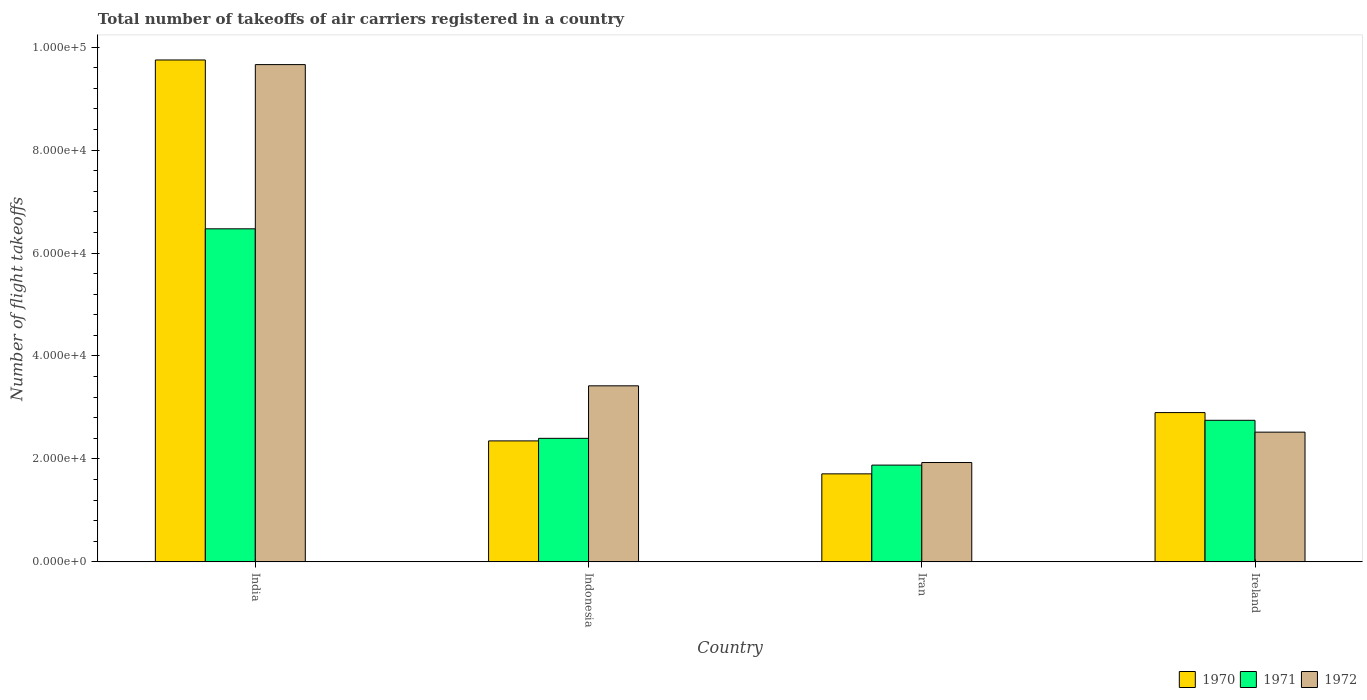How many different coloured bars are there?
Offer a terse response. 3. What is the label of the 3rd group of bars from the left?
Make the answer very short. Iran. What is the total number of flight takeoffs in 1970 in Indonesia?
Provide a succinct answer. 2.35e+04. Across all countries, what is the maximum total number of flight takeoffs in 1971?
Provide a short and direct response. 6.47e+04. Across all countries, what is the minimum total number of flight takeoffs in 1970?
Make the answer very short. 1.71e+04. In which country was the total number of flight takeoffs in 1970 maximum?
Make the answer very short. India. In which country was the total number of flight takeoffs in 1972 minimum?
Keep it short and to the point. Iran. What is the total total number of flight takeoffs in 1971 in the graph?
Provide a short and direct response. 1.35e+05. What is the difference between the total number of flight takeoffs in 1970 in India and that in Indonesia?
Offer a very short reply. 7.40e+04. What is the difference between the total number of flight takeoffs in 1972 in India and the total number of flight takeoffs in 1971 in Iran?
Keep it short and to the point. 7.78e+04. What is the average total number of flight takeoffs in 1972 per country?
Give a very brief answer. 4.38e+04. What is the difference between the total number of flight takeoffs of/in 1972 and total number of flight takeoffs of/in 1970 in Iran?
Your answer should be compact. 2200. What is the ratio of the total number of flight takeoffs in 1971 in India to that in Ireland?
Make the answer very short. 2.35. Is the difference between the total number of flight takeoffs in 1972 in Indonesia and Ireland greater than the difference between the total number of flight takeoffs in 1970 in Indonesia and Ireland?
Provide a short and direct response. Yes. What is the difference between the highest and the second highest total number of flight takeoffs in 1972?
Keep it short and to the point. 7.14e+04. What is the difference between the highest and the lowest total number of flight takeoffs in 1972?
Offer a very short reply. 7.73e+04. Is it the case that in every country, the sum of the total number of flight takeoffs in 1971 and total number of flight takeoffs in 1972 is greater than the total number of flight takeoffs in 1970?
Offer a terse response. Yes. How many bars are there?
Ensure brevity in your answer.  12. Are all the bars in the graph horizontal?
Provide a succinct answer. No. Does the graph contain any zero values?
Provide a short and direct response. No. What is the title of the graph?
Provide a succinct answer. Total number of takeoffs of air carriers registered in a country. What is the label or title of the Y-axis?
Keep it short and to the point. Number of flight takeoffs. What is the Number of flight takeoffs of 1970 in India?
Offer a very short reply. 9.75e+04. What is the Number of flight takeoffs in 1971 in India?
Offer a terse response. 6.47e+04. What is the Number of flight takeoffs of 1972 in India?
Provide a succinct answer. 9.66e+04. What is the Number of flight takeoffs of 1970 in Indonesia?
Your response must be concise. 2.35e+04. What is the Number of flight takeoffs in 1971 in Indonesia?
Your answer should be very brief. 2.40e+04. What is the Number of flight takeoffs in 1972 in Indonesia?
Offer a very short reply. 3.42e+04. What is the Number of flight takeoffs in 1970 in Iran?
Your answer should be compact. 1.71e+04. What is the Number of flight takeoffs of 1971 in Iran?
Ensure brevity in your answer.  1.88e+04. What is the Number of flight takeoffs of 1972 in Iran?
Ensure brevity in your answer.  1.93e+04. What is the Number of flight takeoffs in 1970 in Ireland?
Provide a succinct answer. 2.90e+04. What is the Number of flight takeoffs of 1971 in Ireland?
Offer a very short reply. 2.75e+04. What is the Number of flight takeoffs in 1972 in Ireland?
Ensure brevity in your answer.  2.52e+04. Across all countries, what is the maximum Number of flight takeoffs in 1970?
Your answer should be compact. 9.75e+04. Across all countries, what is the maximum Number of flight takeoffs in 1971?
Your answer should be very brief. 6.47e+04. Across all countries, what is the maximum Number of flight takeoffs of 1972?
Make the answer very short. 9.66e+04. Across all countries, what is the minimum Number of flight takeoffs of 1970?
Your response must be concise. 1.71e+04. Across all countries, what is the minimum Number of flight takeoffs in 1971?
Your response must be concise. 1.88e+04. Across all countries, what is the minimum Number of flight takeoffs in 1972?
Offer a very short reply. 1.93e+04. What is the total Number of flight takeoffs of 1970 in the graph?
Provide a short and direct response. 1.67e+05. What is the total Number of flight takeoffs of 1971 in the graph?
Ensure brevity in your answer.  1.35e+05. What is the total Number of flight takeoffs of 1972 in the graph?
Provide a succinct answer. 1.75e+05. What is the difference between the Number of flight takeoffs of 1970 in India and that in Indonesia?
Ensure brevity in your answer.  7.40e+04. What is the difference between the Number of flight takeoffs of 1971 in India and that in Indonesia?
Your answer should be compact. 4.07e+04. What is the difference between the Number of flight takeoffs in 1972 in India and that in Indonesia?
Ensure brevity in your answer.  6.24e+04. What is the difference between the Number of flight takeoffs in 1970 in India and that in Iran?
Provide a succinct answer. 8.04e+04. What is the difference between the Number of flight takeoffs of 1971 in India and that in Iran?
Make the answer very short. 4.59e+04. What is the difference between the Number of flight takeoffs of 1972 in India and that in Iran?
Your response must be concise. 7.73e+04. What is the difference between the Number of flight takeoffs in 1970 in India and that in Ireland?
Offer a very short reply. 6.85e+04. What is the difference between the Number of flight takeoffs in 1971 in India and that in Ireland?
Your response must be concise. 3.72e+04. What is the difference between the Number of flight takeoffs of 1972 in India and that in Ireland?
Provide a short and direct response. 7.14e+04. What is the difference between the Number of flight takeoffs of 1970 in Indonesia and that in Iran?
Make the answer very short. 6400. What is the difference between the Number of flight takeoffs of 1971 in Indonesia and that in Iran?
Your answer should be very brief. 5200. What is the difference between the Number of flight takeoffs of 1972 in Indonesia and that in Iran?
Your answer should be very brief. 1.49e+04. What is the difference between the Number of flight takeoffs of 1970 in Indonesia and that in Ireland?
Your answer should be compact. -5500. What is the difference between the Number of flight takeoffs in 1971 in Indonesia and that in Ireland?
Offer a very short reply. -3500. What is the difference between the Number of flight takeoffs in 1972 in Indonesia and that in Ireland?
Your answer should be compact. 9000. What is the difference between the Number of flight takeoffs in 1970 in Iran and that in Ireland?
Your answer should be very brief. -1.19e+04. What is the difference between the Number of flight takeoffs in 1971 in Iran and that in Ireland?
Offer a terse response. -8700. What is the difference between the Number of flight takeoffs of 1972 in Iran and that in Ireland?
Make the answer very short. -5900. What is the difference between the Number of flight takeoffs of 1970 in India and the Number of flight takeoffs of 1971 in Indonesia?
Provide a short and direct response. 7.35e+04. What is the difference between the Number of flight takeoffs in 1970 in India and the Number of flight takeoffs in 1972 in Indonesia?
Make the answer very short. 6.33e+04. What is the difference between the Number of flight takeoffs of 1971 in India and the Number of flight takeoffs of 1972 in Indonesia?
Make the answer very short. 3.05e+04. What is the difference between the Number of flight takeoffs of 1970 in India and the Number of flight takeoffs of 1971 in Iran?
Ensure brevity in your answer.  7.87e+04. What is the difference between the Number of flight takeoffs of 1970 in India and the Number of flight takeoffs of 1972 in Iran?
Offer a very short reply. 7.82e+04. What is the difference between the Number of flight takeoffs in 1971 in India and the Number of flight takeoffs in 1972 in Iran?
Give a very brief answer. 4.54e+04. What is the difference between the Number of flight takeoffs in 1970 in India and the Number of flight takeoffs in 1972 in Ireland?
Ensure brevity in your answer.  7.23e+04. What is the difference between the Number of flight takeoffs in 1971 in India and the Number of flight takeoffs in 1972 in Ireland?
Ensure brevity in your answer.  3.95e+04. What is the difference between the Number of flight takeoffs of 1970 in Indonesia and the Number of flight takeoffs of 1971 in Iran?
Provide a succinct answer. 4700. What is the difference between the Number of flight takeoffs in 1970 in Indonesia and the Number of flight takeoffs in 1972 in Iran?
Your response must be concise. 4200. What is the difference between the Number of flight takeoffs in 1971 in Indonesia and the Number of flight takeoffs in 1972 in Iran?
Ensure brevity in your answer.  4700. What is the difference between the Number of flight takeoffs of 1970 in Indonesia and the Number of flight takeoffs of 1971 in Ireland?
Provide a short and direct response. -4000. What is the difference between the Number of flight takeoffs of 1970 in Indonesia and the Number of flight takeoffs of 1972 in Ireland?
Offer a very short reply. -1700. What is the difference between the Number of flight takeoffs of 1971 in Indonesia and the Number of flight takeoffs of 1972 in Ireland?
Your answer should be compact. -1200. What is the difference between the Number of flight takeoffs in 1970 in Iran and the Number of flight takeoffs in 1971 in Ireland?
Keep it short and to the point. -1.04e+04. What is the difference between the Number of flight takeoffs in 1970 in Iran and the Number of flight takeoffs in 1972 in Ireland?
Provide a succinct answer. -8100. What is the difference between the Number of flight takeoffs of 1971 in Iran and the Number of flight takeoffs of 1972 in Ireland?
Your answer should be compact. -6400. What is the average Number of flight takeoffs of 1970 per country?
Offer a very short reply. 4.18e+04. What is the average Number of flight takeoffs in 1971 per country?
Make the answer very short. 3.38e+04. What is the average Number of flight takeoffs in 1972 per country?
Offer a very short reply. 4.38e+04. What is the difference between the Number of flight takeoffs of 1970 and Number of flight takeoffs of 1971 in India?
Offer a very short reply. 3.28e+04. What is the difference between the Number of flight takeoffs in 1970 and Number of flight takeoffs in 1972 in India?
Keep it short and to the point. 900. What is the difference between the Number of flight takeoffs of 1971 and Number of flight takeoffs of 1972 in India?
Ensure brevity in your answer.  -3.19e+04. What is the difference between the Number of flight takeoffs of 1970 and Number of flight takeoffs of 1971 in Indonesia?
Your answer should be compact. -500. What is the difference between the Number of flight takeoffs in 1970 and Number of flight takeoffs in 1972 in Indonesia?
Ensure brevity in your answer.  -1.07e+04. What is the difference between the Number of flight takeoffs of 1971 and Number of flight takeoffs of 1972 in Indonesia?
Your response must be concise. -1.02e+04. What is the difference between the Number of flight takeoffs in 1970 and Number of flight takeoffs in 1971 in Iran?
Your answer should be compact. -1700. What is the difference between the Number of flight takeoffs in 1970 and Number of flight takeoffs in 1972 in Iran?
Your answer should be very brief. -2200. What is the difference between the Number of flight takeoffs in 1971 and Number of flight takeoffs in 1972 in Iran?
Your answer should be very brief. -500. What is the difference between the Number of flight takeoffs of 1970 and Number of flight takeoffs of 1971 in Ireland?
Offer a very short reply. 1500. What is the difference between the Number of flight takeoffs in 1970 and Number of flight takeoffs in 1972 in Ireland?
Your answer should be very brief. 3800. What is the difference between the Number of flight takeoffs in 1971 and Number of flight takeoffs in 1972 in Ireland?
Keep it short and to the point. 2300. What is the ratio of the Number of flight takeoffs of 1970 in India to that in Indonesia?
Ensure brevity in your answer.  4.15. What is the ratio of the Number of flight takeoffs in 1971 in India to that in Indonesia?
Provide a succinct answer. 2.7. What is the ratio of the Number of flight takeoffs in 1972 in India to that in Indonesia?
Keep it short and to the point. 2.82. What is the ratio of the Number of flight takeoffs in 1970 in India to that in Iran?
Provide a short and direct response. 5.7. What is the ratio of the Number of flight takeoffs of 1971 in India to that in Iran?
Keep it short and to the point. 3.44. What is the ratio of the Number of flight takeoffs of 1972 in India to that in Iran?
Offer a very short reply. 5.01. What is the ratio of the Number of flight takeoffs in 1970 in India to that in Ireland?
Keep it short and to the point. 3.36. What is the ratio of the Number of flight takeoffs of 1971 in India to that in Ireland?
Offer a terse response. 2.35. What is the ratio of the Number of flight takeoffs in 1972 in India to that in Ireland?
Make the answer very short. 3.83. What is the ratio of the Number of flight takeoffs of 1970 in Indonesia to that in Iran?
Your answer should be very brief. 1.37. What is the ratio of the Number of flight takeoffs of 1971 in Indonesia to that in Iran?
Ensure brevity in your answer.  1.28. What is the ratio of the Number of flight takeoffs in 1972 in Indonesia to that in Iran?
Your answer should be very brief. 1.77. What is the ratio of the Number of flight takeoffs of 1970 in Indonesia to that in Ireland?
Your response must be concise. 0.81. What is the ratio of the Number of flight takeoffs in 1971 in Indonesia to that in Ireland?
Provide a short and direct response. 0.87. What is the ratio of the Number of flight takeoffs in 1972 in Indonesia to that in Ireland?
Keep it short and to the point. 1.36. What is the ratio of the Number of flight takeoffs in 1970 in Iran to that in Ireland?
Keep it short and to the point. 0.59. What is the ratio of the Number of flight takeoffs of 1971 in Iran to that in Ireland?
Give a very brief answer. 0.68. What is the ratio of the Number of flight takeoffs in 1972 in Iran to that in Ireland?
Offer a very short reply. 0.77. What is the difference between the highest and the second highest Number of flight takeoffs of 1970?
Your answer should be very brief. 6.85e+04. What is the difference between the highest and the second highest Number of flight takeoffs of 1971?
Your response must be concise. 3.72e+04. What is the difference between the highest and the second highest Number of flight takeoffs of 1972?
Make the answer very short. 6.24e+04. What is the difference between the highest and the lowest Number of flight takeoffs of 1970?
Make the answer very short. 8.04e+04. What is the difference between the highest and the lowest Number of flight takeoffs in 1971?
Ensure brevity in your answer.  4.59e+04. What is the difference between the highest and the lowest Number of flight takeoffs in 1972?
Your answer should be very brief. 7.73e+04. 